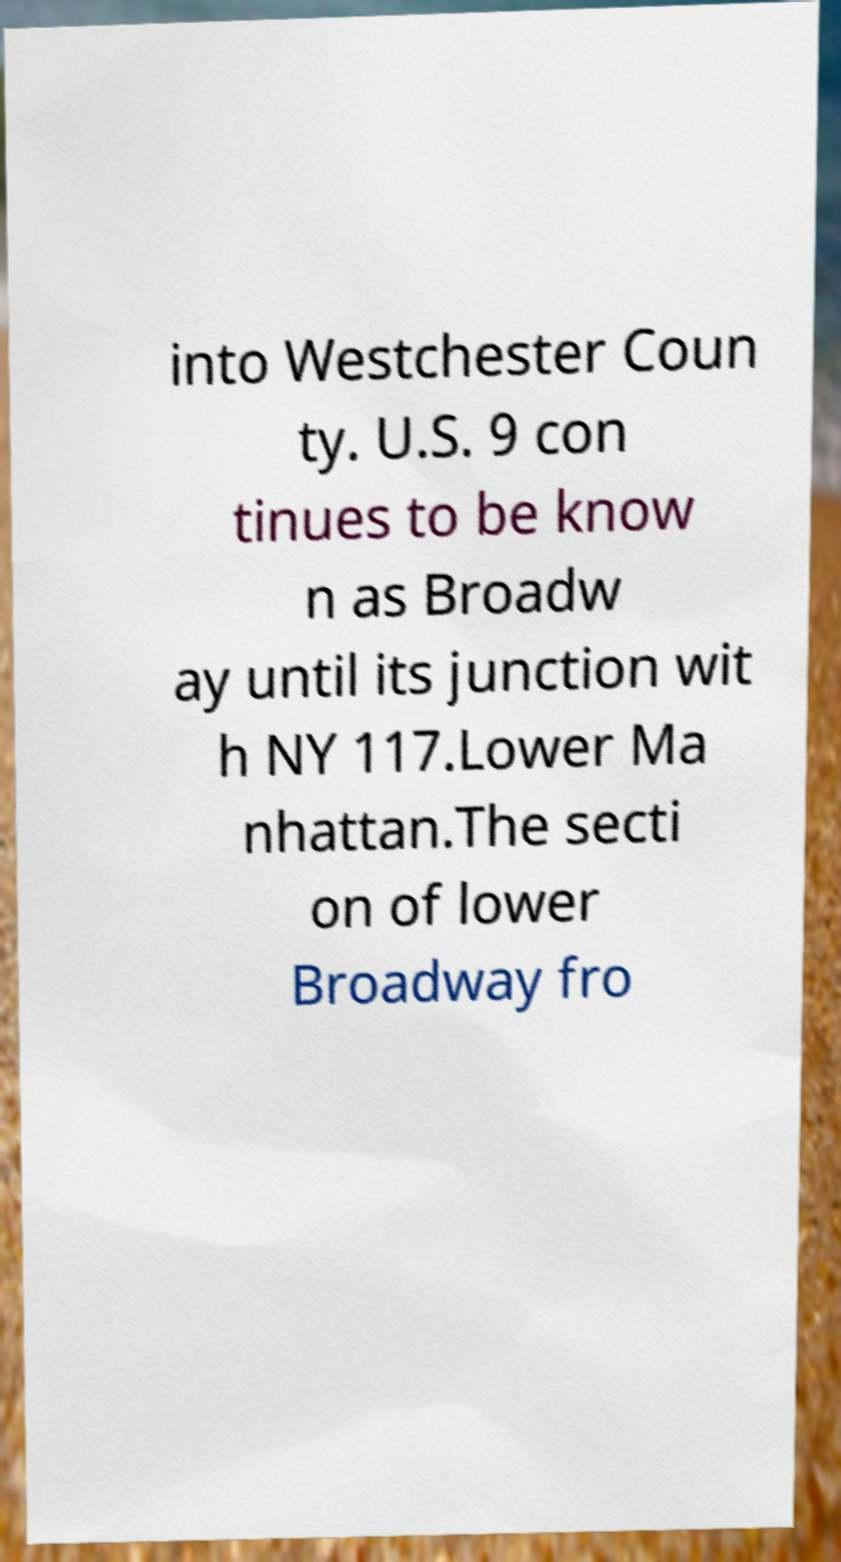I need the written content from this picture converted into text. Can you do that? into Westchester Coun ty. U.S. 9 con tinues to be know n as Broadw ay until its junction wit h NY 117.Lower Ma nhattan.The secti on of lower Broadway fro 